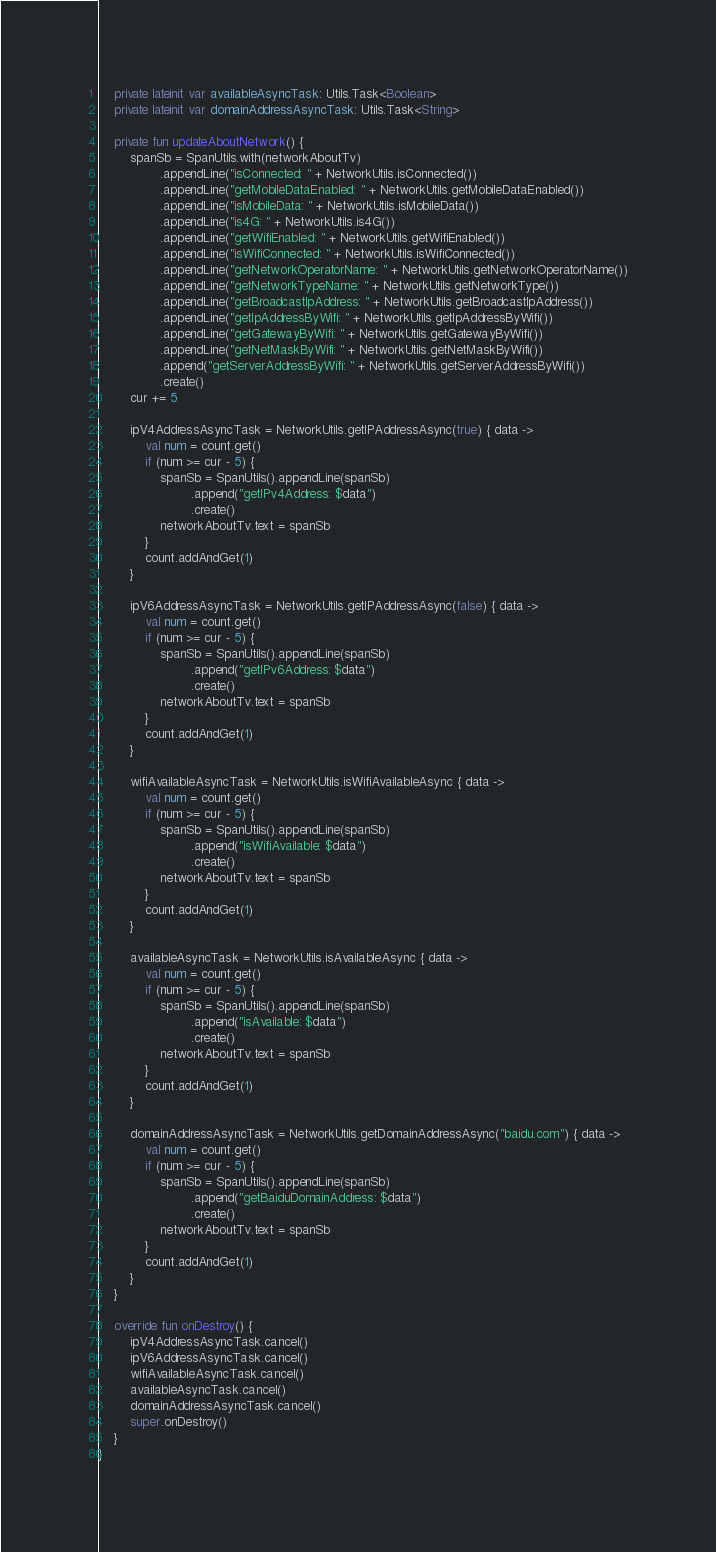<code> <loc_0><loc_0><loc_500><loc_500><_Kotlin_>    private lateinit var availableAsyncTask: Utils.Task<Boolean>
    private lateinit var domainAddressAsyncTask: Utils.Task<String>

    private fun updateAboutNetwork() {
        spanSb = SpanUtils.with(networkAboutTv)
                .appendLine("isConnected: " + NetworkUtils.isConnected())
                .appendLine("getMobileDataEnabled: " + NetworkUtils.getMobileDataEnabled())
                .appendLine("isMobileData: " + NetworkUtils.isMobileData())
                .appendLine("is4G: " + NetworkUtils.is4G())
                .appendLine("getWifiEnabled: " + NetworkUtils.getWifiEnabled())
                .appendLine("isWifiConnected: " + NetworkUtils.isWifiConnected())
                .appendLine("getNetworkOperatorName: " + NetworkUtils.getNetworkOperatorName())
                .appendLine("getNetworkTypeName: " + NetworkUtils.getNetworkType())
                .appendLine("getBroadcastIpAddress: " + NetworkUtils.getBroadcastIpAddress())
                .appendLine("getIpAddressByWifi: " + NetworkUtils.getIpAddressByWifi())
                .appendLine("getGatewayByWifi: " + NetworkUtils.getGatewayByWifi())
                .appendLine("getNetMaskByWifi: " + NetworkUtils.getNetMaskByWifi())
                .append("getServerAddressByWifi: " + NetworkUtils.getServerAddressByWifi())
                .create()
        cur += 5

        ipV4AddressAsyncTask = NetworkUtils.getIPAddressAsync(true) { data ->
            val num = count.get()
            if (num >= cur - 5) {
                spanSb = SpanUtils().appendLine(spanSb)
                        .append("getIPv4Address: $data")
                        .create()
                networkAboutTv.text = spanSb
            }
            count.addAndGet(1)
        }

        ipV6AddressAsyncTask = NetworkUtils.getIPAddressAsync(false) { data ->
            val num = count.get()
            if (num >= cur - 5) {
                spanSb = SpanUtils().appendLine(spanSb)
                        .append("getIPv6Address: $data")
                        .create()
                networkAboutTv.text = spanSb
            }
            count.addAndGet(1)
        }

        wifiAvailableAsyncTask = NetworkUtils.isWifiAvailableAsync { data ->
            val num = count.get()
            if (num >= cur - 5) {
                spanSb = SpanUtils().appendLine(spanSb)
                        .append("isWifiAvailable: $data")
                        .create()
                networkAboutTv.text = spanSb
            }
            count.addAndGet(1)
        }

        availableAsyncTask = NetworkUtils.isAvailableAsync { data ->
            val num = count.get()
            if (num >= cur - 5) {
                spanSb = SpanUtils().appendLine(spanSb)
                        .append("isAvailable: $data")
                        .create()
                networkAboutTv.text = spanSb
            }
            count.addAndGet(1)
        }

        domainAddressAsyncTask = NetworkUtils.getDomainAddressAsync("baidu.com") { data ->
            val num = count.get()
            if (num >= cur - 5) {
                spanSb = SpanUtils().appendLine(spanSb)
                        .append("getBaiduDomainAddress: $data")
                        .create()
                networkAboutTv.text = spanSb
            }
            count.addAndGet(1)
        }
    }

    override fun onDestroy() {
        ipV4AddressAsyncTask.cancel()
        ipV6AddressAsyncTask.cancel()
        wifiAvailableAsyncTask.cancel()
        availableAsyncTask.cancel()
        domainAddressAsyncTask.cancel()
        super.onDestroy()
    }
}
</code> 